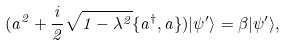Convert formula to latex. <formula><loc_0><loc_0><loc_500><loc_500>( a ^ { 2 } + \frac { i } { 2 } \sqrt { 1 - \lambda ^ { 2 } } \{ a ^ { \dagger } , a \} ) | \psi ^ { \prime } \rangle = \beta | \psi ^ { \prime } \rangle ,</formula> 